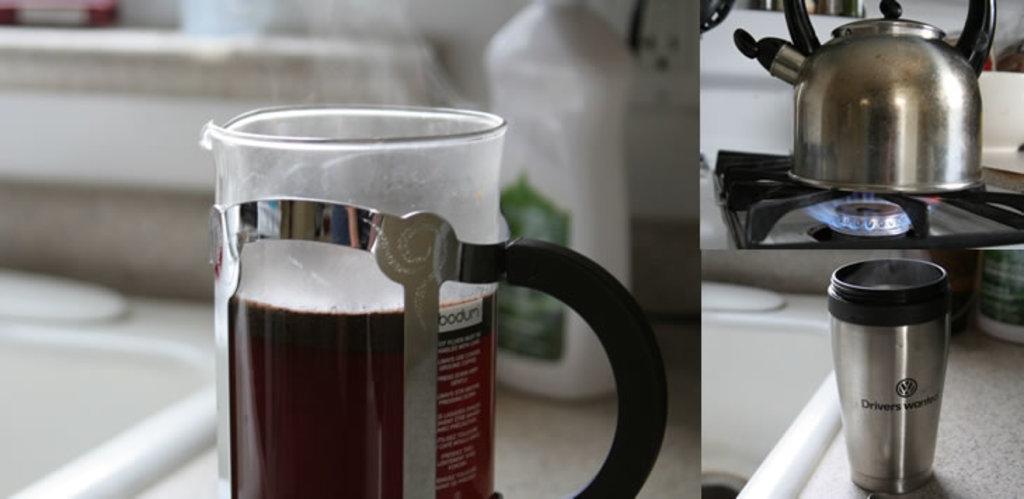In one or two sentences, can you explain what this image depicts? In this image we can see a collage picture of two images on the left side there is a coffee mud and a bottle in the background, on the right side there is a glass and a kettle on the stove. 